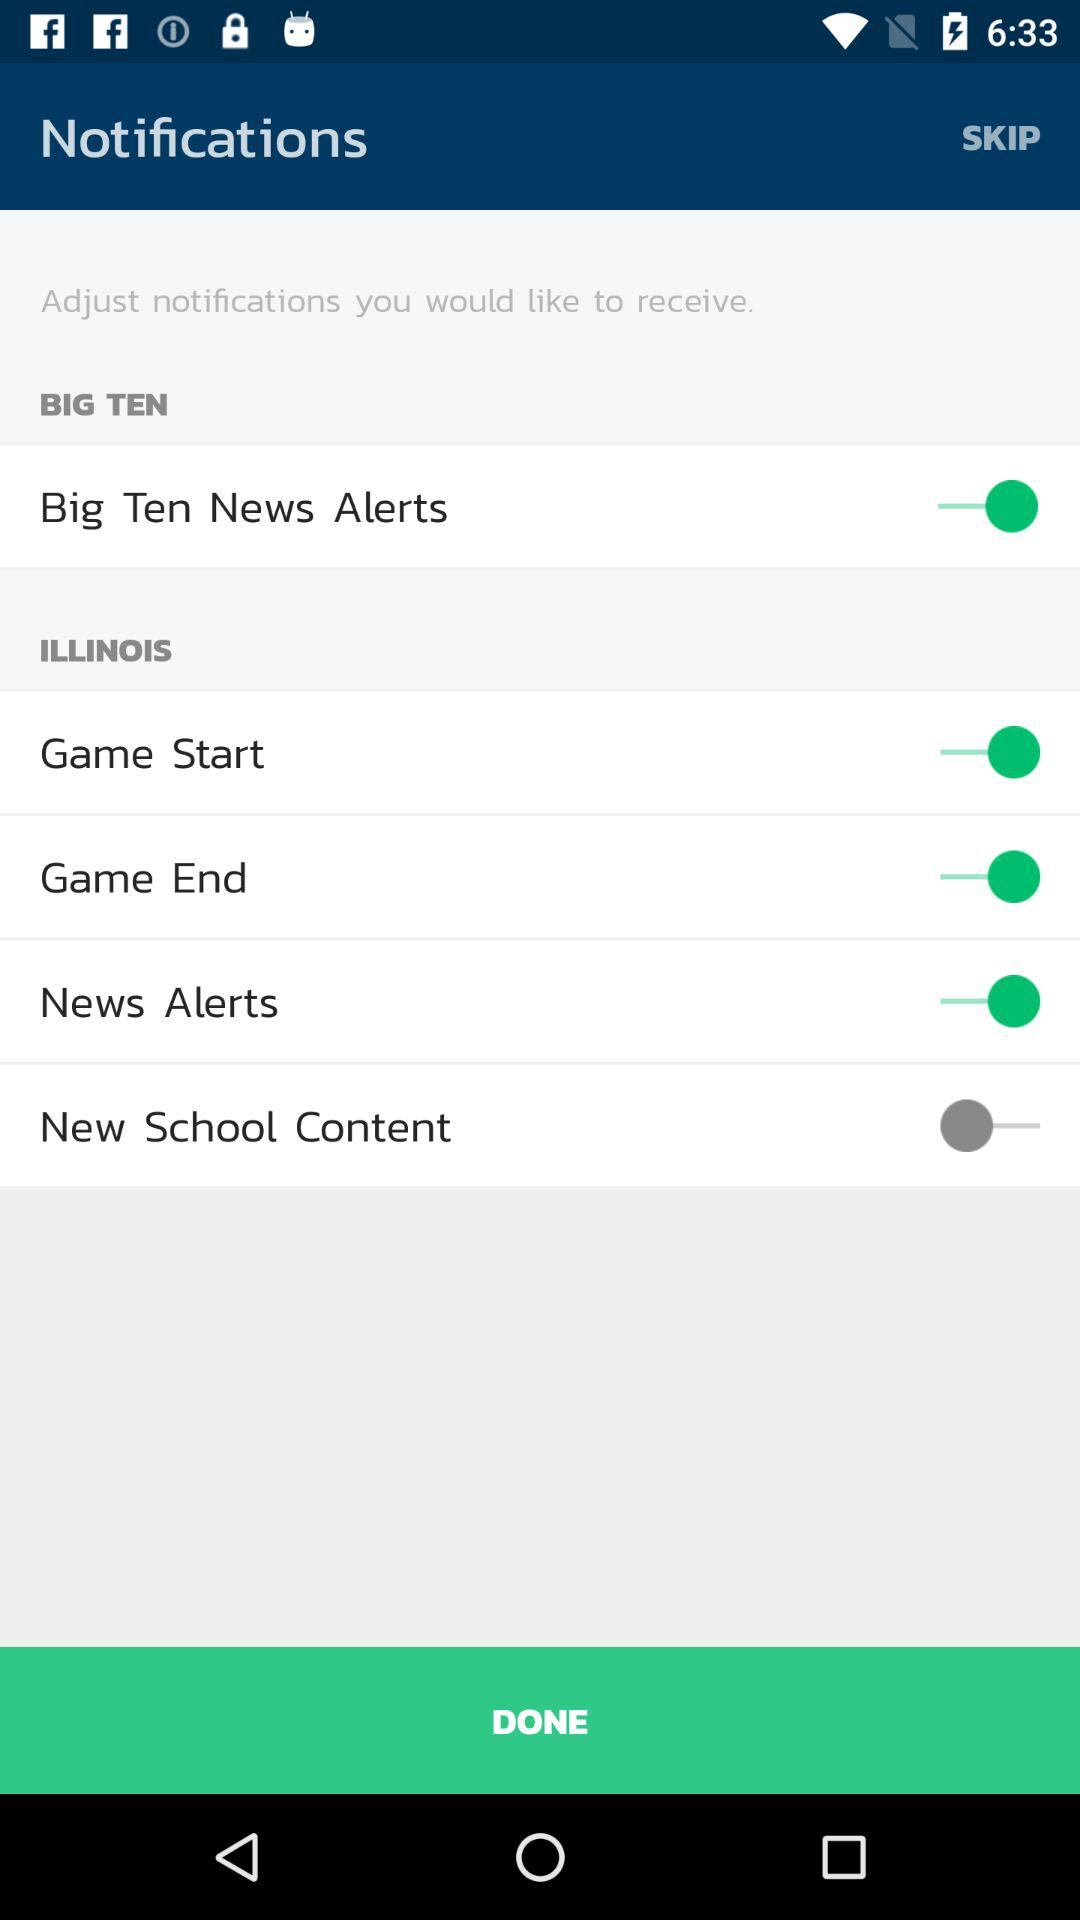What is the status of the "Big Ten News Alerts"? The status is "on". 